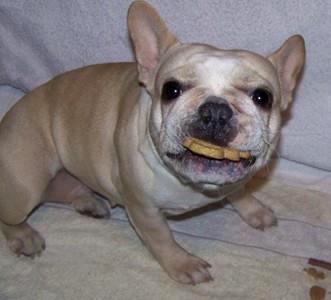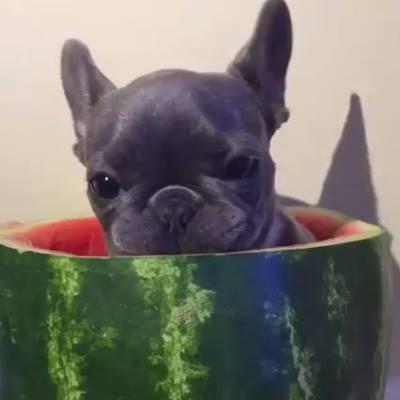The first image is the image on the left, the second image is the image on the right. Considering the images on both sides, is "One image features a dog next to a half-peeled banana." valid? Answer yes or no. No. The first image is the image on the left, the second image is the image on the right. Examine the images to the left and right. Is the description "One image shows a dog with its face near a peeled banana shape." accurate? Answer yes or no. No. 